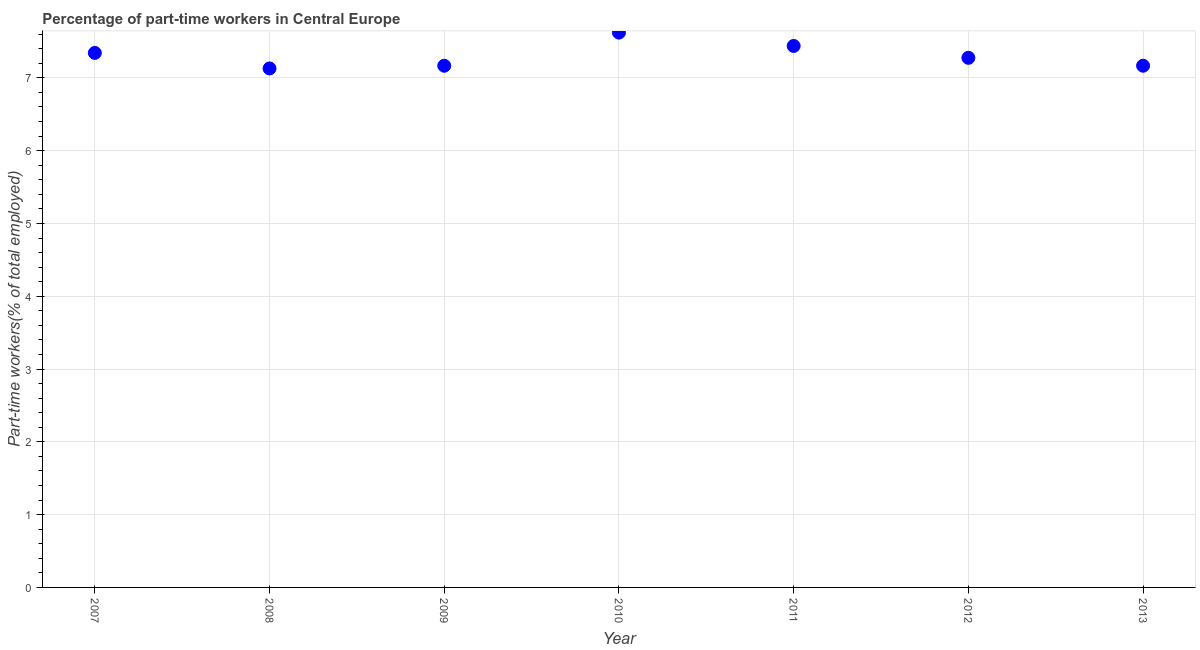What is the percentage of part-time workers in 2012?
Offer a very short reply. 7.28. Across all years, what is the maximum percentage of part-time workers?
Ensure brevity in your answer.  7.62. Across all years, what is the minimum percentage of part-time workers?
Make the answer very short. 7.13. In which year was the percentage of part-time workers maximum?
Keep it short and to the point. 2010. What is the sum of the percentage of part-time workers?
Ensure brevity in your answer.  51.14. What is the difference between the percentage of part-time workers in 2007 and 2009?
Provide a succinct answer. 0.18. What is the average percentage of part-time workers per year?
Your answer should be very brief. 7.31. What is the median percentage of part-time workers?
Offer a very short reply. 7.28. In how many years, is the percentage of part-time workers greater than 1.6 %?
Your answer should be compact. 7. What is the ratio of the percentage of part-time workers in 2009 to that in 2012?
Your response must be concise. 0.99. What is the difference between the highest and the second highest percentage of part-time workers?
Provide a succinct answer. 0.18. What is the difference between the highest and the lowest percentage of part-time workers?
Keep it short and to the point. 0.49. In how many years, is the percentage of part-time workers greater than the average percentage of part-time workers taken over all years?
Give a very brief answer. 3. How many years are there in the graph?
Give a very brief answer. 7. Does the graph contain any zero values?
Your response must be concise. No. What is the title of the graph?
Offer a very short reply. Percentage of part-time workers in Central Europe. What is the label or title of the Y-axis?
Your response must be concise. Part-time workers(% of total employed). What is the Part-time workers(% of total employed) in 2007?
Provide a short and direct response. 7.34. What is the Part-time workers(% of total employed) in 2008?
Your answer should be compact. 7.13. What is the Part-time workers(% of total employed) in 2009?
Give a very brief answer. 7.17. What is the Part-time workers(% of total employed) in 2010?
Offer a very short reply. 7.62. What is the Part-time workers(% of total employed) in 2011?
Ensure brevity in your answer.  7.44. What is the Part-time workers(% of total employed) in 2012?
Offer a terse response. 7.28. What is the Part-time workers(% of total employed) in 2013?
Your answer should be very brief. 7.17. What is the difference between the Part-time workers(% of total employed) in 2007 and 2008?
Provide a succinct answer. 0.21. What is the difference between the Part-time workers(% of total employed) in 2007 and 2009?
Provide a succinct answer. 0.18. What is the difference between the Part-time workers(% of total employed) in 2007 and 2010?
Ensure brevity in your answer.  -0.28. What is the difference between the Part-time workers(% of total employed) in 2007 and 2011?
Provide a short and direct response. -0.1. What is the difference between the Part-time workers(% of total employed) in 2007 and 2012?
Your response must be concise. 0.07. What is the difference between the Part-time workers(% of total employed) in 2007 and 2013?
Provide a short and direct response. 0.18. What is the difference between the Part-time workers(% of total employed) in 2008 and 2009?
Your answer should be very brief. -0.04. What is the difference between the Part-time workers(% of total employed) in 2008 and 2010?
Offer a terse response. -0.49. What is the difference between the Part-time workers(% of total employed) in 2008 and 2011?
Offer a very short reply. -0.31. What is the difference between the Part-time workers(% of total employed) in 2008 and 2012?
Your answer should be very brief. -0.15. What is the difference between the Part-time workers(% of total employed) in 2008 and 2013?
Offer a terse response. -0.04. What is the difference between the Part-time workers(% of total employed) in 2009 and 2010?
Provide a short and direct response. -0.46. What is the difference between the Part-time workers(% of total employed) in 2009 and 2011?
Keep it short and to the point. -0.27. What is the difference between the Part-time workers(% of total employed) in 2009 and 2012?
Your answer should be compact. -0.11. What is the difference between the Part-time workers(% of total employed) in 2009 and 2013?
Offer a terse response. -0. What is the difference between the Part-time workers(% of total employed) in 2010 and 2011?
Ensure brevity in your answer.  0.18. What is the difference between the Part-time workers(% of total employed) in 2010 and 2012?
Give a very brief answer. 0.35. What is the difference between the Part-time workers(% of total employed) in 2010 and 2013?
Offer a terse response. 0.45. What is the difference between the Part-time workers(% of total employed) in 2011 and 2012?
Provide a succinct answer. 0.16. What is the difference between the Part-time workers(% of total employed) in 2011 and 2013?
Give a very brief answer. 0.27. What is the difference between the Part-time workers(% of total employed) in 2012 and 2013?
Your answer should be very brief. 0.11. What is the ratio of the Part-time workers(% of total employed) in 2007 to that in 2011?
Make the answer very short. 0.99. What is the ratio of the Part-time workers(% of total employed) in 2008 to that in 2009?
Ensure brevity in your answer.  0.99. What is the ratio of the Part-time workers(% of total employed) in 2008 to that in 2010?
Your response must be concise. 0.94. What is the ratio of the Part-time workers(% of total employed) in 2008 to that in 2011?
Ensure brevity in your answer.  0.96. What is the ratio of the Part-time workers(% of total employed) in 2008 to that in 2012?
Your answer should be compact. 0.98. What is the ratio of the Part-time workers(% of total employed) in 2008 to that in 2013?
Provide a short and direct response. 0.99. What is the ratio of the Part-time workers(% of total employed) in 2009 to that in 2010?
Provide a succinct answer. 0.94. What is the ratio of the Part-time workers(% of total employed) in 2009 to that in 2011?
Offer a very short reply. 0.96. What is the ratio of the Part-time workers(% of total employed) in 2010 to that in 2012?
Offer a terse response. 1.05. What is the ratio of the Part-time workers(% of total employed) in 2010 to that in 2013?
Keep it short and to the point. 1.06. What is the ratio of the Part-time workers(% of total employed) in 2011 to that in 2012?
Offer a very short reply. 1.02. What is the ratio of the Part-time workers(% of total employed) in 2011 to that in 2013?
Give a very brief answer. 1.04. 